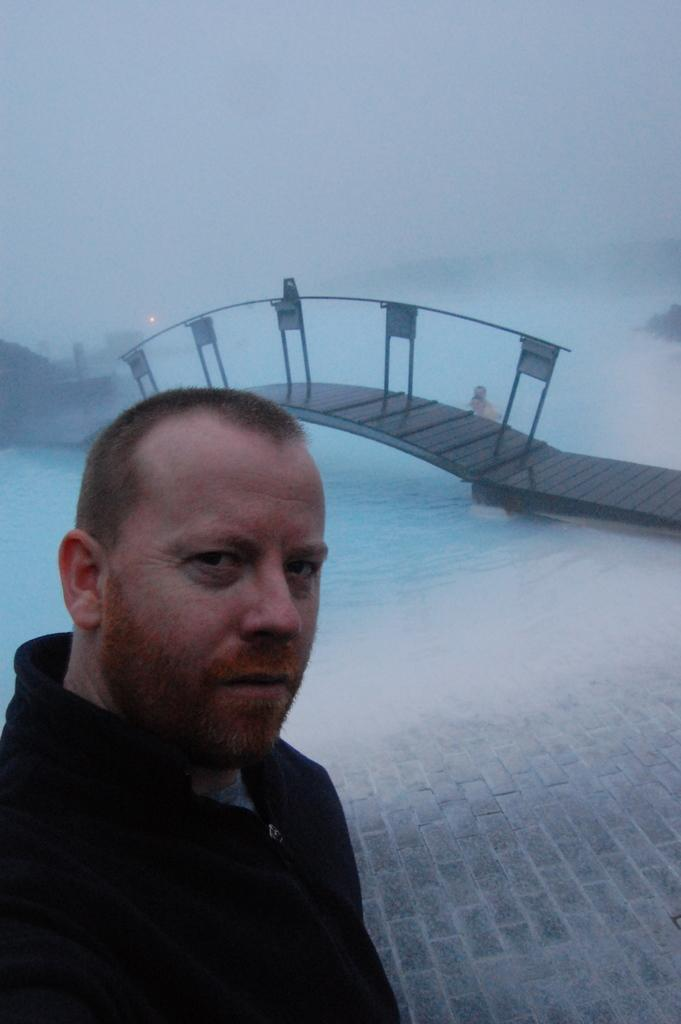Who or what is on the left side of the image? There is a person on the left side of the image. What can be seen at the top of the image? The sky is visible at the top of the image. What structure is located in the middle of the image? There is a bridge in the middle of the image. What is under the bridge in the image? Water is visible under the bridge. Where is the alley located in the image? There is no alley present in the image. What type of sport is being played in the image? There is no sport or volleyball present in the image. 